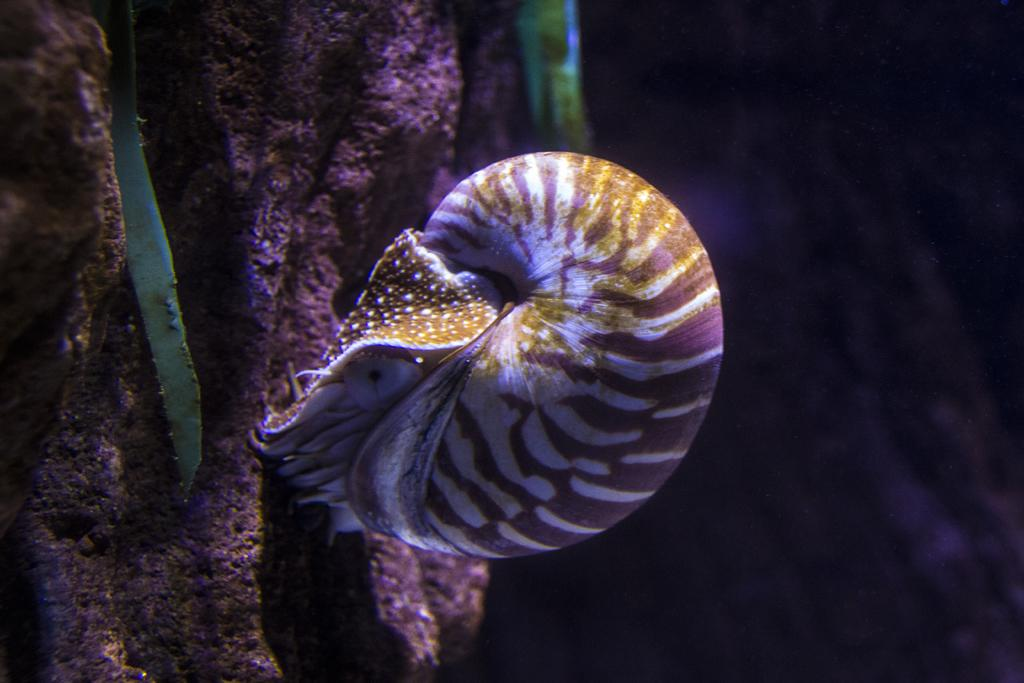What is the main subject of the image? There is a Chambered nautilus in the image. Where is the Chambered nautilus located? The Chambered nautilus is in the water. What can be seen in front of the Chambered nautilus? There is a tree in front of the Chambered nautilus. What type of chin can be seen on the Chambered nautilus in the image? Chambered nautiluses do not have chins, as they are marine mollusks. 